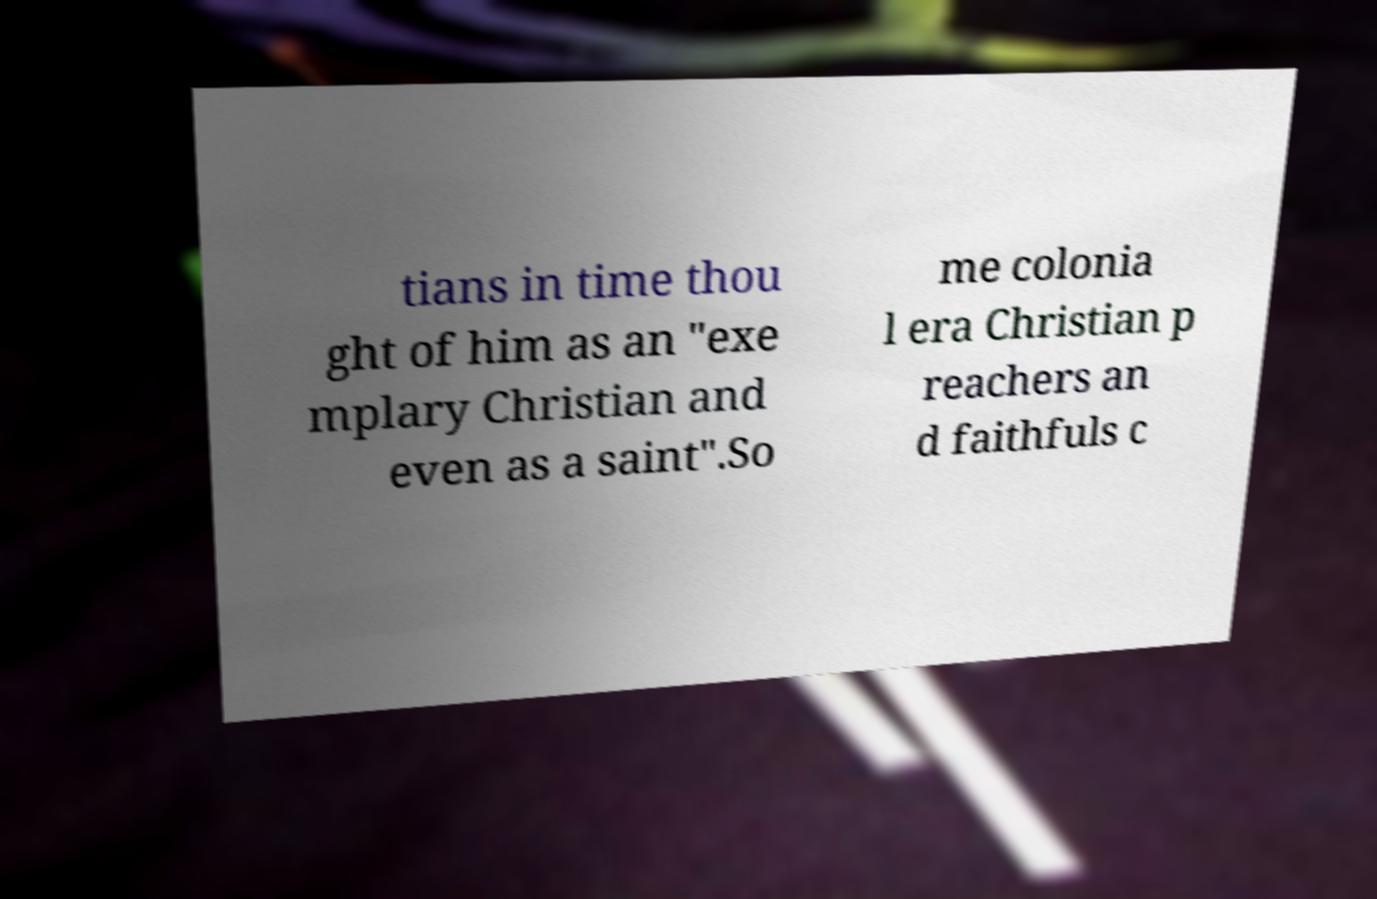Can you read and provide the text displayed in the image?This photo seems to have some interesting text. Can you extract and type it out for me? tians in time thou ght of him as an "exe mplary Christian and even as a saint".So me colonia l era Christian p reachers an d faithfuls c 